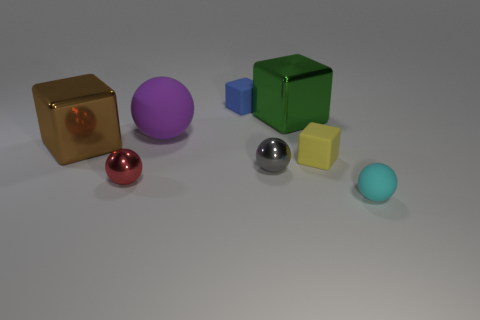Subtract all small red balls. How many balls are left? 3 Subtract 1 balls. How many balls are left? 3 Subtract all green cubes. How many cubes are left? 3 Add 2 large yellow cylinders. How many objects exist? 10 Subtract all cyan spheres. Subtract all gray cubes. How many spheres are left? 3 Subtract all blue spheres. How many brown cubes are left? 1 Subtract all tiny brown rubber balls. Subtract all green cubes. How many objects are left? 7 Add 4 tiny yellow matte things. How many tiny yellow matte things are left? 5 Add 3 large purple balls. How many large purple balls exist? 4 Subtract 1 red balls. How many objects are left? 7 